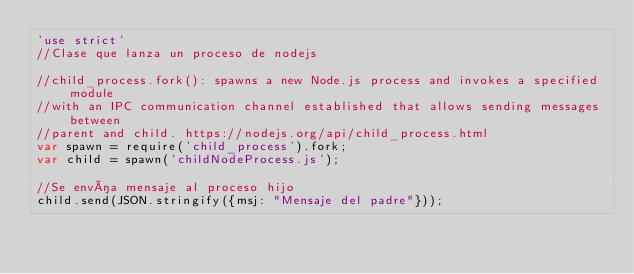<code> <loc_0><loc_0><loc_500><loc_500><_JavaScript_>'use strict'
//Clase que lanza un proceso de nodejs

//child_process.fork(): spawns a new Node.js process and invokes a specified module
//with an IPC communication channel established that allows sending messages between 
//parent and child. https://nodejs.org/api/child_process.html
var spawn = require('child_process').fork;
var child = spawn('childNodeProcess.js');

//Se envía mensaje al proceso hijo
child.send(JSON.stringify({msj: "Mensaje del padre"}));
</code> 